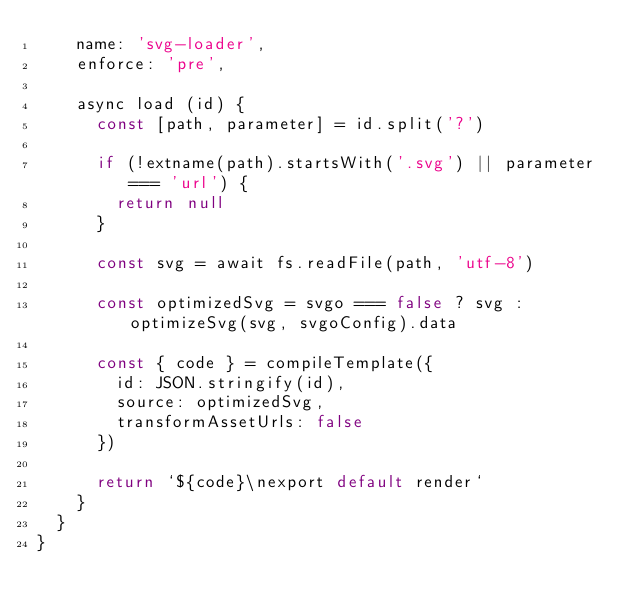Convert code to text. <code><loc_0><loc_0><loc_500><loc_500><_JavaScript_>    name: 'svg-loader',
    enforce: 'pre',

    async load (id) {
      const [path, parameter] = id.split('?')

      if (!extname(path).startsWith('.svg') || parameter === 'url') {
        return null
      }

      const svg = await fs.readFile(path, 'utf-8')

      const optimizedSvg = svgo === false ? svg : optimizeSvg(svg, svgoConfig).data

      const { code } = compileTemplate({
        id: JSON.stringify(id),
        source: optimizedSvg,
        transformAssetUrls: false
      })

      return `${code}\nexport default render`
    }
  }
}
</code> 